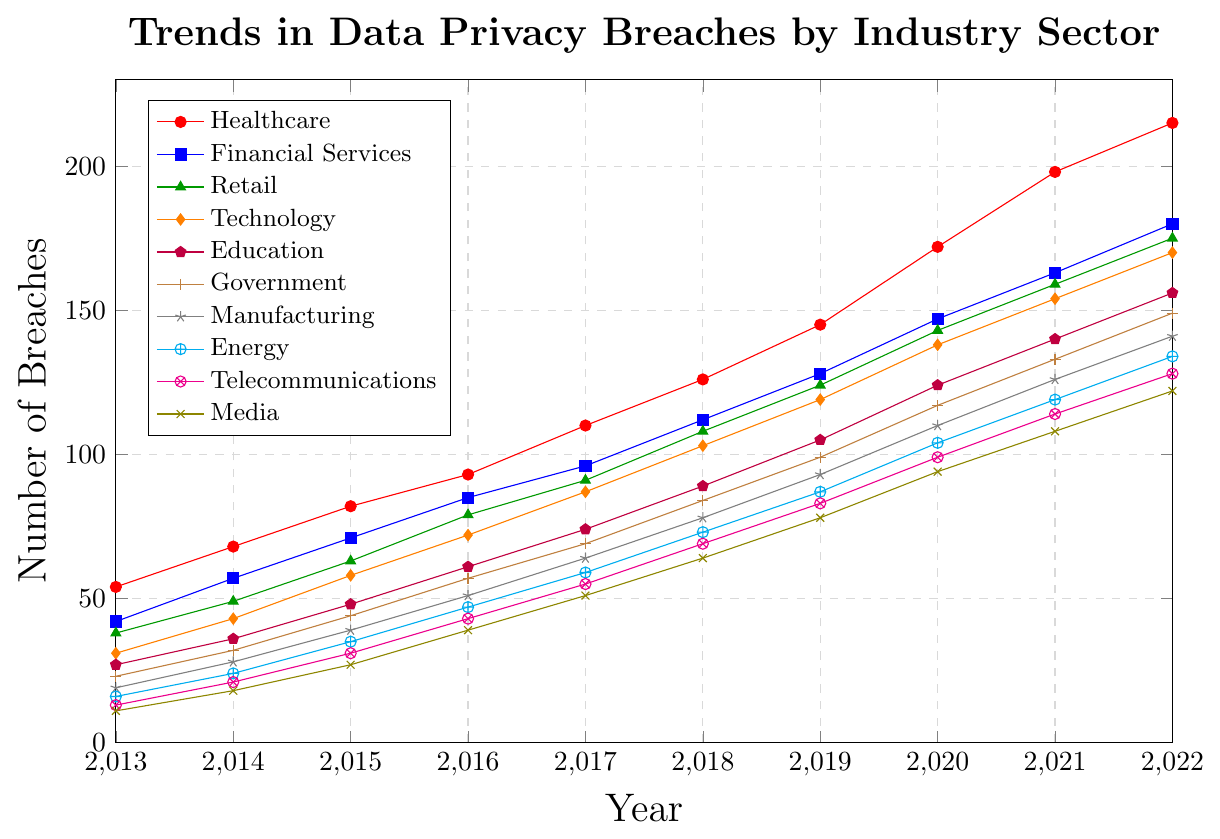Which industry had the highest number of breaches in 2022? Look at the endpoint values of each line in 2022 and identify the highest one. Healthcare had 215 breaches in 2022.
Answer: Healthcare Which industry saw the largest increase in breaches from 2013 to 2022? Calculate the difference between the values in 2022 and 2013 for each industry. Healthcare increased by 161 breaches (215 - 54), which is the largest increase.
Answer: Healthcare What was the number of breaches in the Financial Services sector in 2017? Find the value for Financial Services in 2017 by locating the corresponding point on the chart. The number of breaches is 96.
Answer: 96 Between 2016 and 2017, which industry experienced a higher increase in breaches, Education or Media? Calculate the differences between 2016 and 2017 for both industries. Education increased by 13 (74 - 61) and Media increased by 12 (51 - 39), so Education had a higher increase.
Answer: Education Comparing Retail and Telecommunications, which sector had more breaches in 2020? Locate the values for Retail and Telecommunications in 2020. Retail had 143 breaches, while Telecommunications had 99 breaches, so Retail had more.
Answer: Retail Which industry had the lowest number of breaches in 2019? Identify the lowest endpoint value for 2019 among all lines. Media had the lowest number with 78 breaches.
Answer: Media Was there any year in which the Government sector had more breaches than the Technology sector? Compare the values of Government and Technology for each year. In every year, the Technology sector had more breaches than the Government sector, so no.
Answer: No In which year did the Energy sector surpass the Manufacturing sector in breaches? Compare the values for each year to identify when Energy's breaches become greater than Manufacturing's breaches. In 2021, Energy had 119 breaches which surpassed Manufacturing’s 126 breaches in 2022.
Answer: 2021 How many breaches did the Healthcare sector have on average per year from 2013 to 2022? Sum the values of Healthcare from 2013 to 2022 and then divide by the number of years (10). (54 + 68 + 82 + 93 + 110 + 126 + 145 + 172 + 198 + 215) / 10 = 126.3
Answer: 126.3 By how much did the number of breaches in the Retail sector increase from 2018 to 2019? Calculate the difference between the values for Retail in 2018 and 2019. The increase is (124 - 108) = 16 breaches.
Answer: 16 